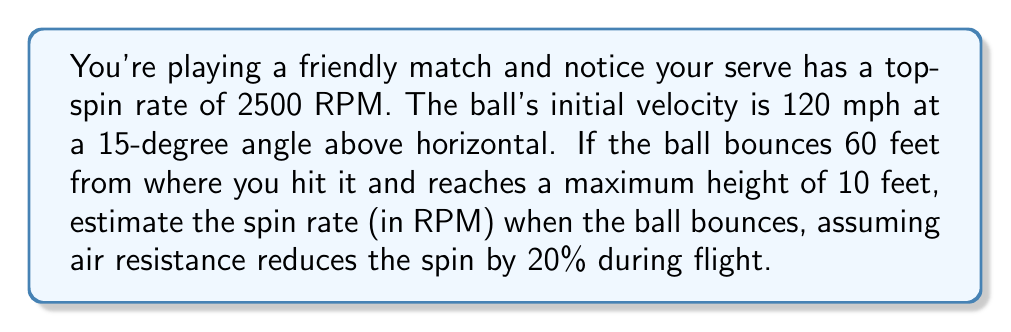Help me with this question. Let's approach this step-by-step:

1) First, we need to understand that the spin rate decreases during the ball's flight due to air resistance. The question states that air resistance reduces the spin by 20%.

2) Initial spin rate: 2500 RPM

3) Reduction in spin rate:
   $$\text{Reduction} = 2500 \times 20\% = 2500 \times 0.20 = 500 \text{ RPM}$$

4) To find the spin rate at bounce:
   $$\text{Spin rate at bounce} = \text{Initial spin rate} - \text{Reduction}$$
   $$\text{Spin rate at bounce} = 2500 - 500 = 2000 \text{ RPM}$$

5) We don't actually need the other information (initial velocity, angle, distance, and height) to solve this particular problem. These details are included to make the question more realistic and to fit the context of a tennis match.
Answer: 2000 RPM 